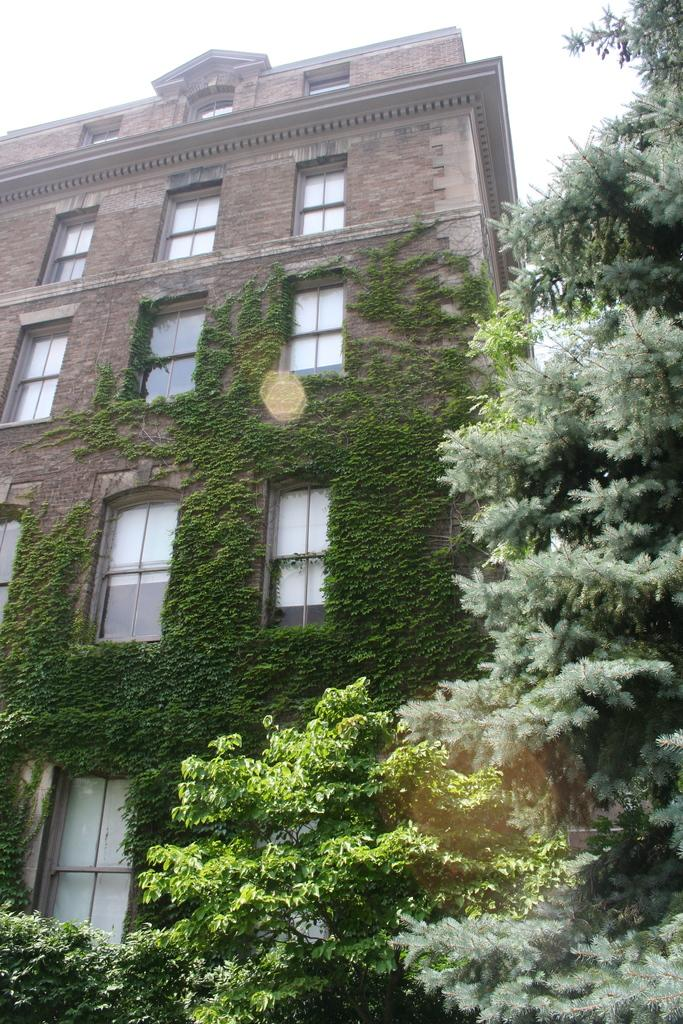What structure is present in the image? There is a building in the image. What feature can be seen on the building? The building has windows. What type of vegetation is visible in the image? There are trees in the image. What part of the trees can be seen in the image? The trees have branches and leaves. How many toes can be seen on the building in the image? There are no toes present on the building in the image. What type of basket is hanging from the branches of the trees in the image? There is no basket hanging from the branches of the trees in the image. 